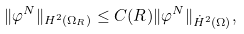Convert formula to latex. <formula><loc_0><loc_0><loc_500><loc_500>\| \varphi ^ { N } \| _ { H ^ { 2 } ( \Omega _ { R } ) } \leq C ( R ) \| \varphi ^ { N } \| _ { \dot { H } ^ { 2 } ( \Omega ) } ,</formula> 